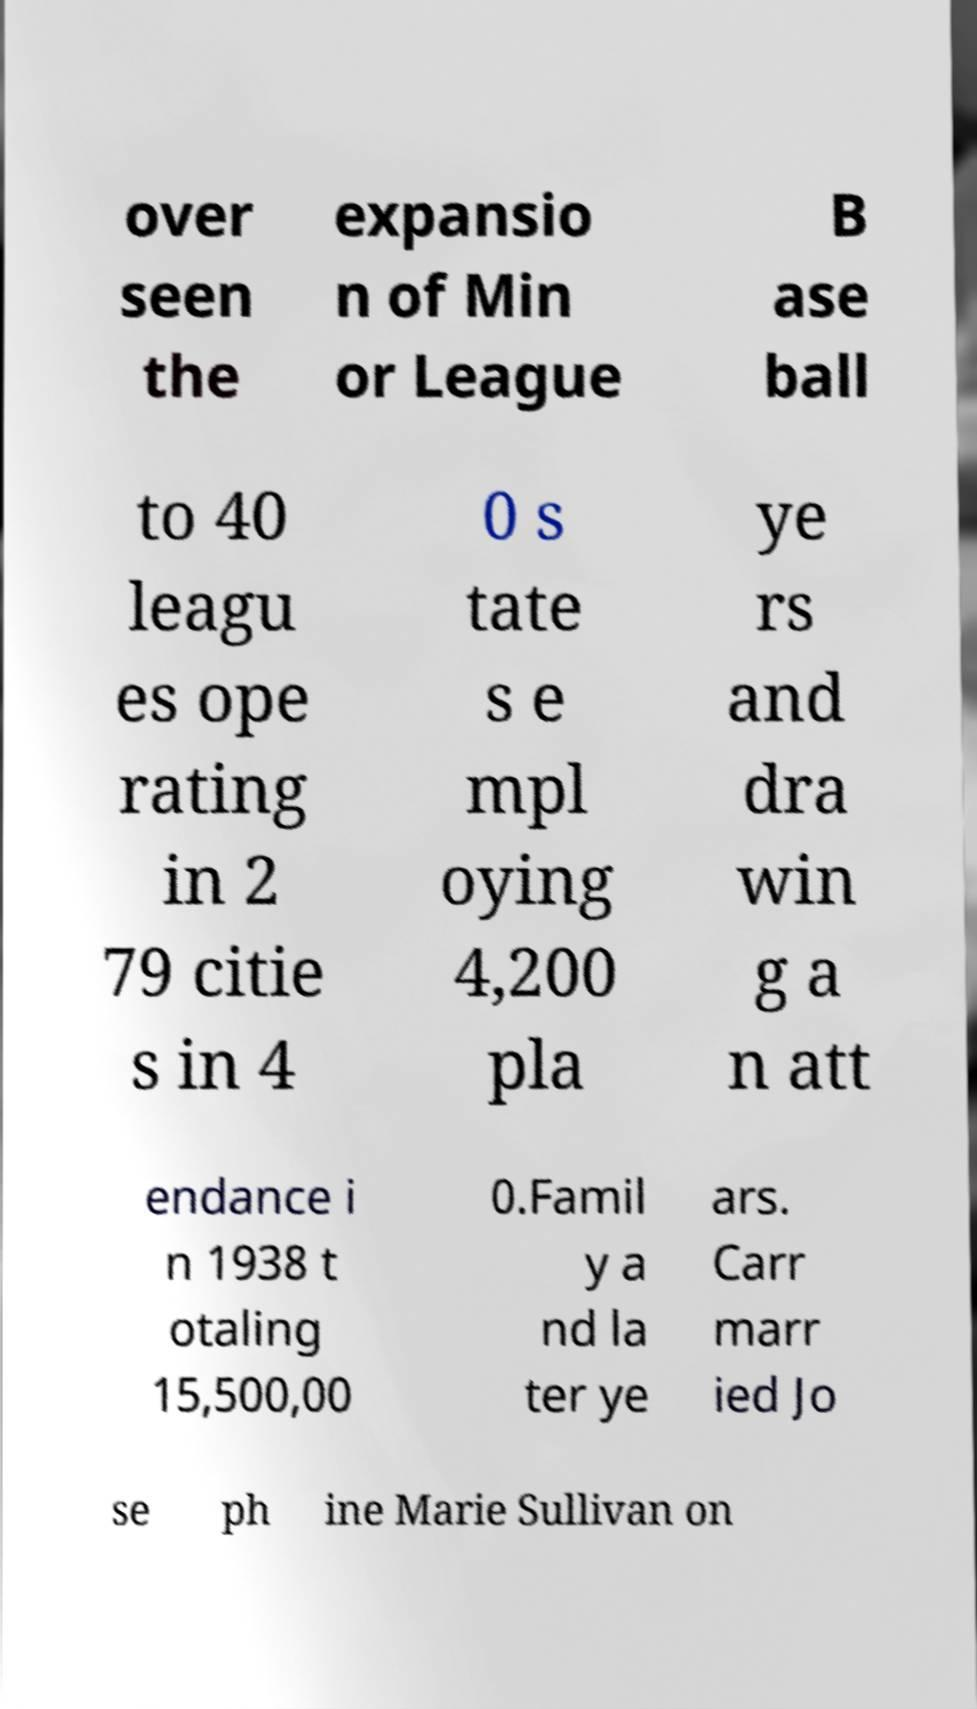Could you assist in decoding the text presented in this image and type it out clearly? over seen the expansio n of Min or League B ase ball to 40 leagu es ope rating in 2 79 citie s in 4 0 s tate s e mpl oying 4,200 pla ye rs and dra win g a n att endance i n 1938 t otaling 15,500,00 0.Famil y a nd la ter ye ars. Carr marr ied Jo se ph ine Marie Sullivan on 